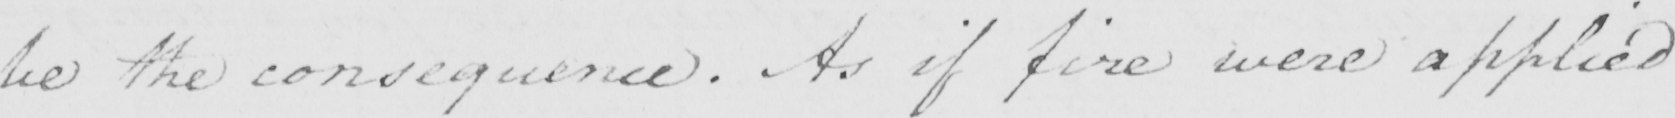What is written in this line of handwriting? be the consequence . As if fire were applied 